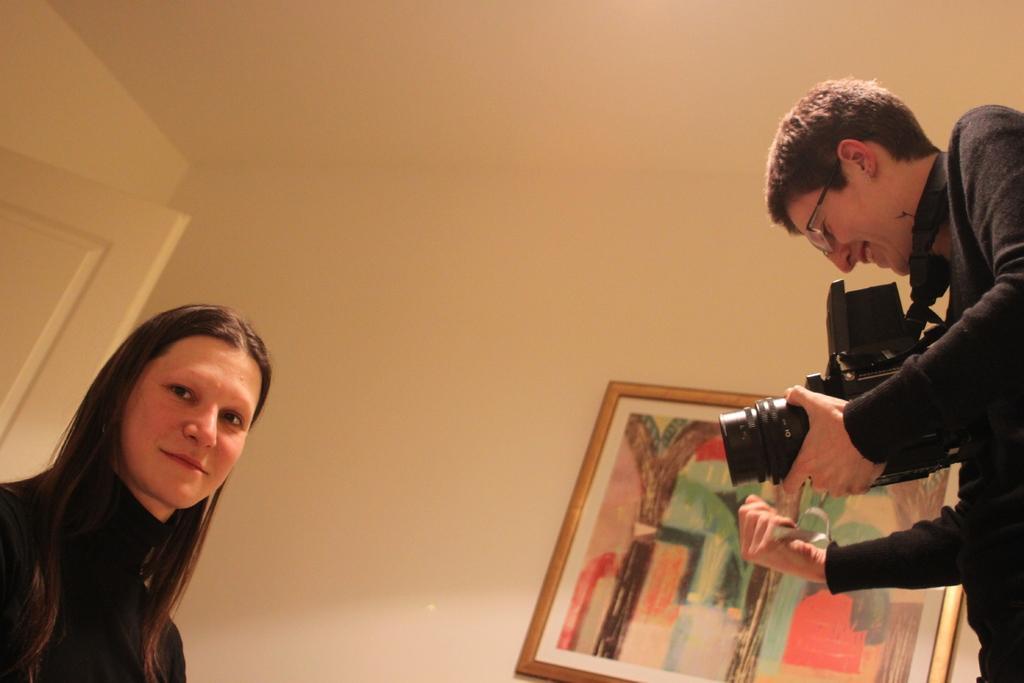Please provide a concise description of this image. In this image I can see two people with black color dresses and one person holding the camera. In the background I can see the frame to the wall. 